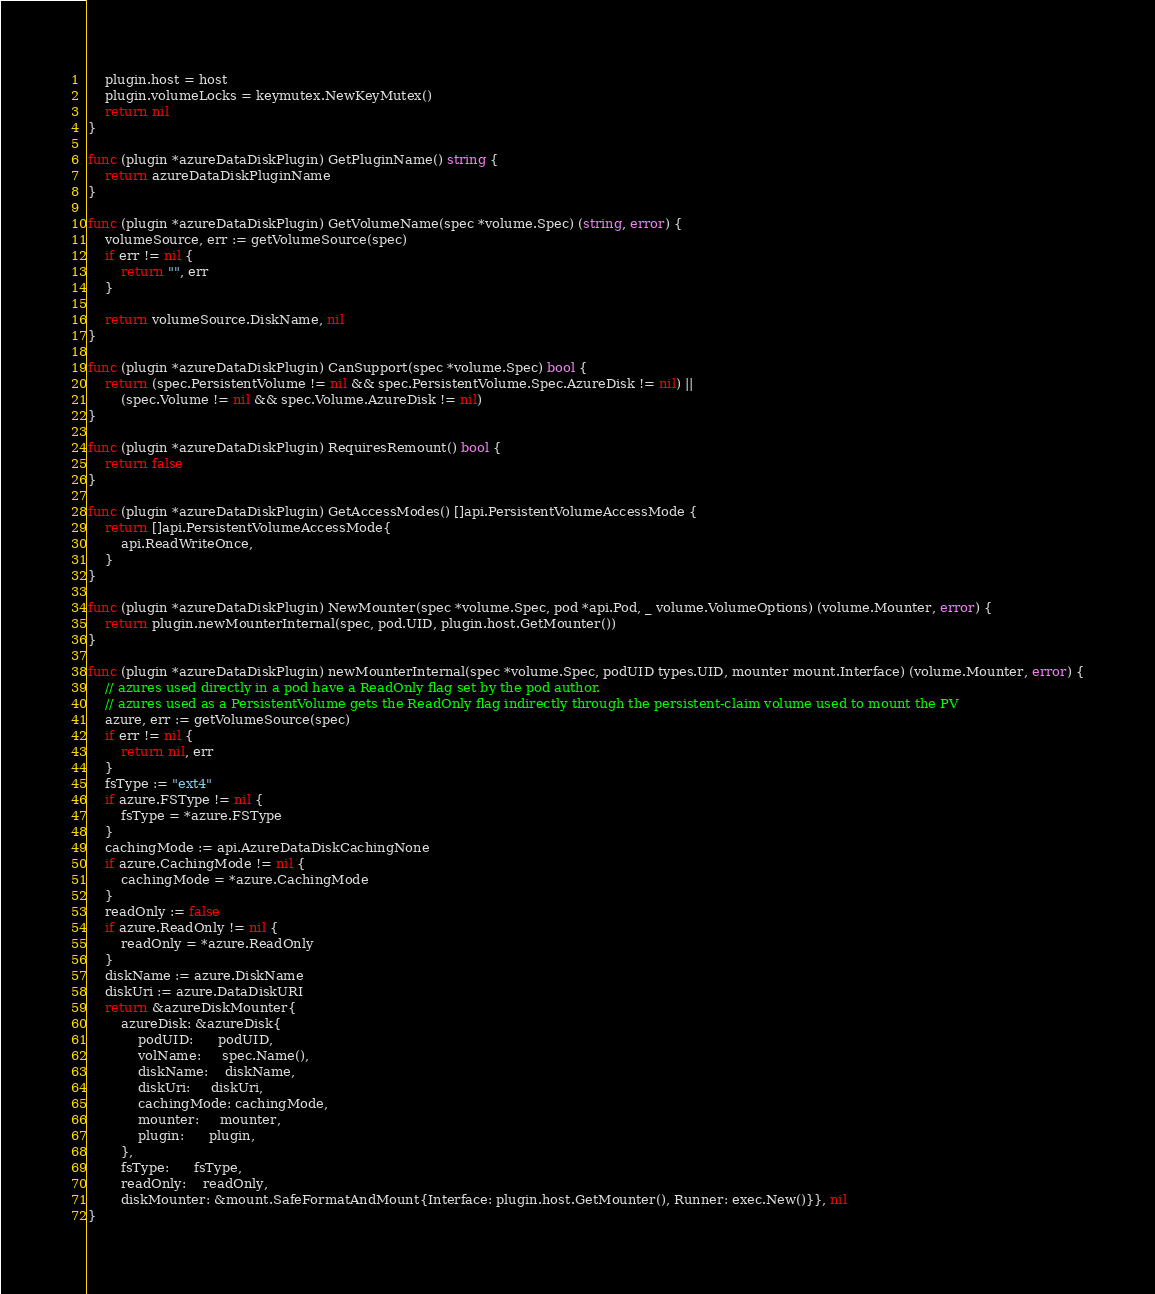Convert code to text. <code><loc_0><loc_0><loc_500><loc_500><_Go_>	plugin.host = host
	plugin.volumeLocks = keymutex.NewKeyMutex()
	return nil
}

func (plugin *azureDataDiskPlugin) GetPluginName() string {
	return azureDataDiskPluginName
}

func (plugin *azureDataDiskPlugin) GetVolumeName(spec *volume.Spec) (string, error) {
	volumeSource, err := getVolumeSource(spec)
	if err != nil {
		return "", err
	}

	return volumeSource.DiskName, nil
}

func (plugin *azureDataDiskPlugin) CanSupport(spec *volume.Spec) bool {
	return (spec.PersistentVolume != nil && spec.PersistentVolume.Spec.AzureDisk != nil) ||
		(spec.Volume != nil && spec.Volume.AzureDisk != nil)
}

func (plugin *azureDataDiskPlugin) RequiresRemount() bool {
	return false
}

func (plugin *azureDataDiskPlugin) GetAccessModes() []api.PersistentVolumeAccessMode {
	return []api.PersistentVolumeAccessMode{
		api.ReadWriteOnce,
	}
}

func (plugin *azureDataDiskPlugin) NewMounter(spec *volume.Spec, pod *api.Pod, _ volume.VolumeOptions) (volume.Mounter, error) {
	return plugin.newMounterInternal(spec, pod.UID, plugin.host.GetMounter())
}

func (plugin *azureDataDiskPlugin) newMounterInternal(spec *volume.Spec, podUID types.UID, mounter mount.Interface) (volume.Mounter, error) {
	// azures used directly in a pod have a ReadOnly flag set by the pod author.
	// azures used as a PersistentVolume gets the ReadOnly flag indirectly through the persistent-claim volume used to mount the PV
	azure, err := getVolumeSource(spec)
	if err != nil {
		return nil, err
	}
	fsType := "ext4"
	if azure.FSType != nil {
		fsType = *azure.FSType
	}
	cachingMode := api.AzureDataDiskCachingNone
	if azure.CachingMode != nil {
		cachingMode = *azure.CachingMode
	}
	readOnly := false
	if azure.ReadOnly != nil {
		readOnly = *azure.ReadOnly
	}
	diskName := azure.DiskName
	diskUri := azure.DataDiskURI
	return &azureDiskMounter{
		azureDisk: &azureDisk{
			podUID:      podUID,
			volName:     spec.Name(),
			diskName:    diskName,
			diskUri:     diskUri,
			cachingMode: cachingMode,
			mounter:     mounter,
			plugin:      plugin,
		},
		fsType:      fsType,
		readOnly:    readOnly,
		diskMounter: &mount.SafeFormatAndMount{Interface: plugin.host.GetMounter(), Runner: exec.New()}}, nil
}
</code> 